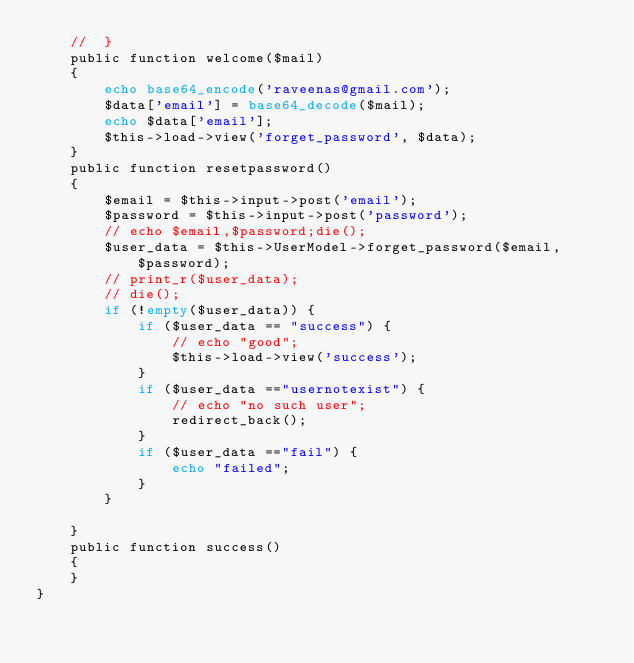Convert code to text. <code><loc_0><loc_0><loc_500><loc_500><_PHP_>	// 	}
	public function welcome($mail)
	{
		echo base64_encode('raveenas@gmail.com');
		$data['email'] = base64_decode($mail);
		echo $data['email'];
		$this->load->view('forget_password', $data);
	}
	public function resetpassword()
	{
		$email = $this->input->post('email');
		$password = $this->input->post('password');
		// echo $email,$password;die();
		$user_data = $this->UserModel->forget_password($email, $password);
		// print_r($user_data);
		// die();
		if (!empty($user_data)) {
			if ($user_data == "success") {
				// echo "good";
				$this->load->view('success');
			}
			if ($user_data =="usernotexist") {
				// echo "no such user";
				redirect_back();
			}
			if ($user_data =="fail") {
				echo "failed";
			}
		}
		
	}
	public function success()
	{
	}
}
</code> 